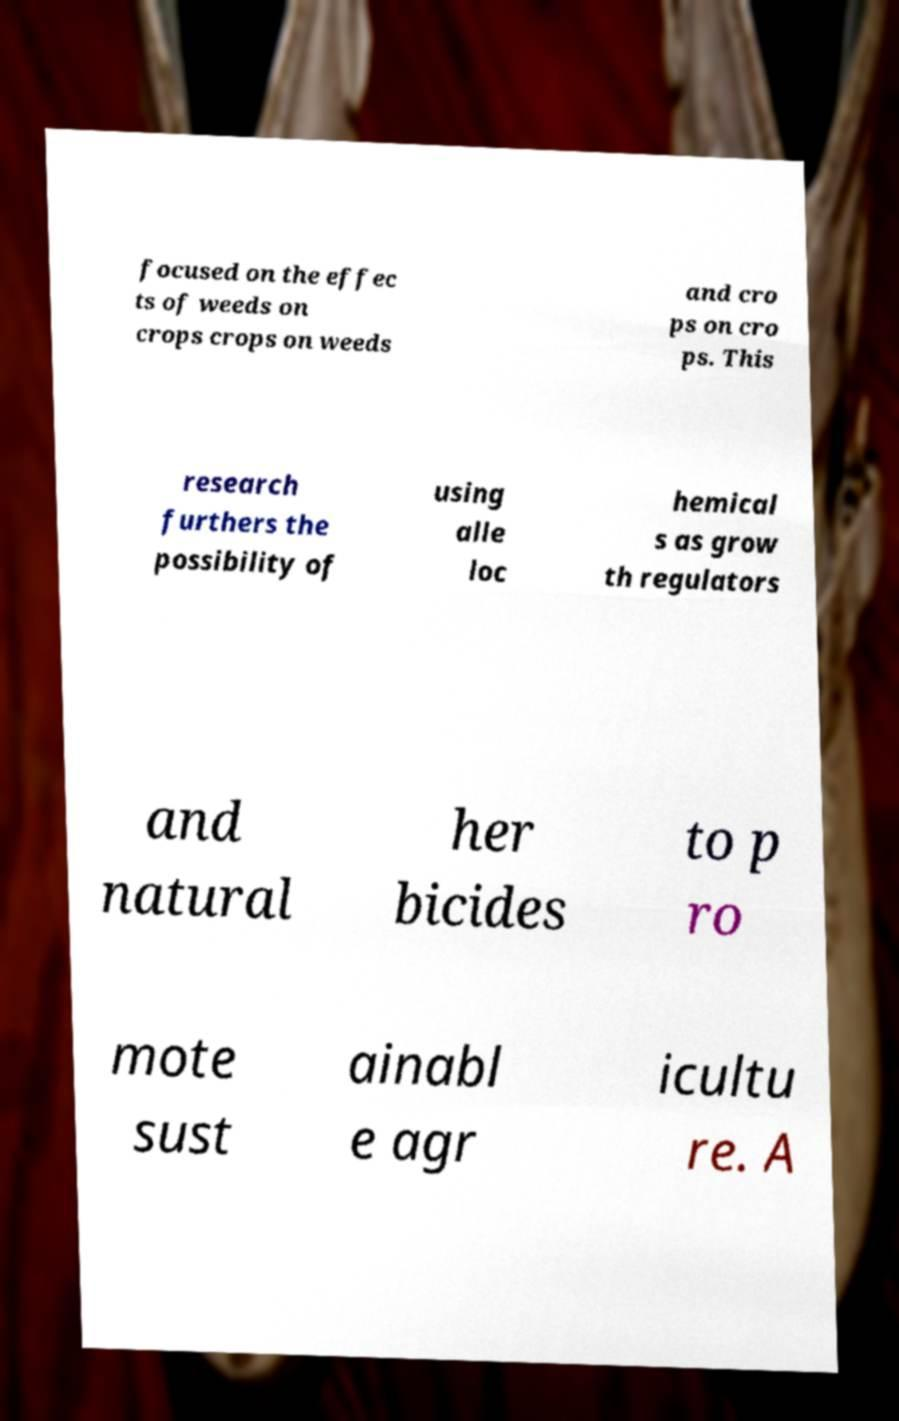Could you assist in decoding the text presented in this image and type it out clearly? focused on the effec ts of weeds on crops crops on weeds and cro ps on cro ps. This research furthers the possibility of using alle loc hemical s as grow th regulators and natural her bicides to p ro mote sust ainabl e agr icultu re. A 